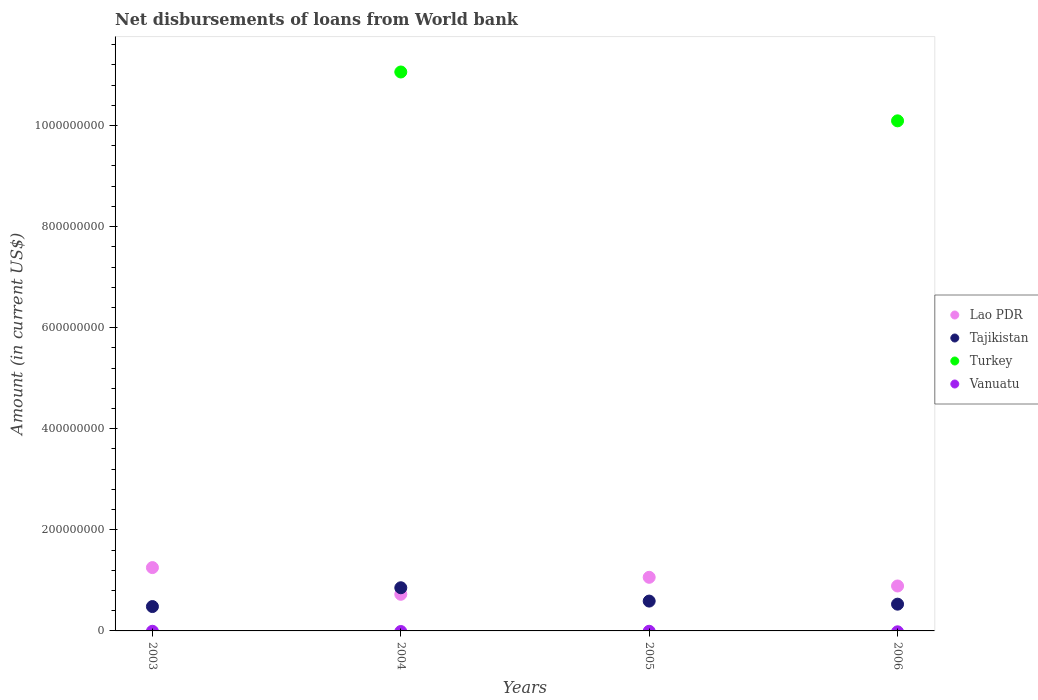How many different coloured dotlines are there?
Offer a very short reply. 3. What is the amount of loan disbursed from World Bank in Tajikistan in 2005?
Your answer should be compact. 5.90e+07. Across all years, what is the maximum amount of loan disbursed from World Bank in Turkey?
Give a very brief answer. 1.11e+09. Across all years, what is the minimum amount of loan disbursed from World Bank in Tajikistan?
Keep it short and to the point. 4.82e+07. In which year was the amount of loan disbursed from World Bank in Lao PDR maximum?
Keep it short and to the point. 2003. What is the total amount of loan disbursed from World Bank in Tajikistan in the graph?
Provide a succinct answer. 2.46e+08. What is the difference between the amount of loan disbursed from World Bank in Tajikistan in 2004 and that in 2006?
Offer a very short reply. 3.25e+07. What is the difference between the amount of loan disbursed from World Bank in Tajikistan in 2006 and the amount of loan disbursed from World Bank in Vanuatu in 2003?
Provide a short and direct response. 5.29e+07. What is the average amount of loan disbursed from World Bank in Vanuatu per year?
Make the answer very short. 0. In the year 2006, what is the difference between the amount of loan disbursed from World Bank in Lao PDR and amount of loan disbursed from World Bank in Turkey?
Provide a short and direct response. -9.20e+08. What is the ratio of the amount of loan disbursed from World Bank in Tajikistan in 2003 to that in 2006?
Give a very brief answer. 0.91. Is the difference between the amount of loan disbursed from World Bank in Lao PDR in 2004 and 2006 greater than the difference between the amount of loan disbursed from World Bank in Turkey in 2004 and 2006?
Provide a succinct answer. No. What is the difference between the highest and the second highest amount of loan disbursed from World Bank in Tajikistan?
Offer a very short reply. 2.64e+07. What is the difference between the highest and the lowest amount of loan disbursed from World Bank in Tajikistan?
Your answer should be very brief. 3.72e+07. In how many years, is the amount of loan disbursed from World Bank in Lao PDR greater than the average amount of loan disbursed from World Bank in Lao PDR taken over all years?
Your answer should be very brief. 2. Does the amount of loan disbursed from World Bank in Lao PDR monotonically increase over the years?
Offer a very short reply. No. Is the amount of loan disbursed from World Bank in Tajikistan strictly greater than the amount of loan disbursed from World Bank in Lao PDR over the years?
Keep it short and to the point. No. Is the amount of loan disbursed from World Bank in Lao PDR strictly less than the amount of loan disbursed from World Bank in Turkey over the years?
Your response must be concise. No. Are the values on the major ticks of Y-axis written in scientific E-notation?
Offer a terse response. No. Does the graph contain any zero values?
Give a very brief answer. Yes. Where does the legend appear in the graph?
Offer a terse response. Center right. What is the title of the graph?
Give a very brief answer. Net disbursements of loans from World bank. Does "Israel" appear as one of the legend labels in the graph?
Offer a very short reply. No. What is the label or title of the X-axis?
Provide a short and direct response. Years. What is the label or title of the Y-axis?
Your answer should be compact. Amount (in current US$). What is the Amount (in current US$) of Lao PDR in 2003?
Offer a very short reply. 1.25e+08. What is the Amount (in current US$) of Tajikistan in 2003?
Offer a very short reply. 4.82e+07. What is the Amount (in current US$) in Vanuatu in 2003?
Keep it short and to the point. 0. What is the Amount (in current US$) of Lao PDR in 2004?
Make the answer very short. 7.25e+07. What is the Amount (in current US$) in Tajikistan in 2004?
Offer a terse response. 8.54e+07. What is the Amount (in current US$) in Turkey in 2004?
Your response must be concise. 1.11e+09. What is the Amount (in current US$) of Vanuatu in 2004?
Your response must be concise. 0. What is the Amount (in current US$) of Lao PDR in 2005?
Make the answer very short. 1.06e+08. What is the Amount (in current US$) in Tajikistan in 2005?
Provide a succinct answer. 5.90e+07. What is the Amount (in current US$) of Turkey in 2005?
Offer a very short reply. 0. What is the Amount (in current US$) in Lao PDR in 2006?
Your response must be concise. 8.89e+07. What is the Amount (in current US$) in Tajikistan in 2006?
Your response must be concise. 5.29e+07. What is the Amount (in current US$) of Turkey in 2006?
Ensure brevity in your answer.  1.01e+09. Across all years, what is the maximum Amount (in current US$) of Lao PDR?
Your response must be concise. 1.25e+08. Across all years, what is the maximum Amount (in current US$) in Tajikistan?
Ensure brevity in your answer.  8.54e+07. Across all years, what is the maximum Amount (in current US$) of Turkey?
Offer a very short reply. 1.11e+09. Across all years, what is the minimum Amount (in current US$) in Lao PDR?
Your response must be concise. 7.25e+07. Across all years, what is the minimum Amount (in current US$) of Tajikistan?
Offer a very short reply. 4.82e+07. Across all years, what is the minimum Amount (in current US$) in Turkey?
Offer a terse response. 0. What is the total Amount (in current US$) of Lao PDR in the graph?
Make the answer very short. 3.93e+08. What is the total Amount (in current US$) of Tajikistan in the graph?
Make the answer very short. 2.46e+08. What is the total Amount (in current US$) of Turkey in the graph?
Your answer should be compact. 2.12e+09. What is the total Amount (in current US$) of Vanuatu in the graph?
Offer a very short reply. 0. What is the difference between the Amount (in current US$) of Lao PDR in 2003 and that in 2004?
Provide a short and direct response. 5.28e+07. What is the difference between the Amount (in current US$) in Tajikistan in 2003 and that in 2004?
Ensure brevity in your answer.  -3.72e+07. What is the difference between the Amount (in current US$) in Lao PDR in 2003 and that in 2005?
Your answer should be compact. 1.92e+07. What is the difference between the Amount (in current US$) of Tajikistan in 2003 and that in 2005?
Your response must be concise. -1.08e+07. What is the difference between the Amount (in current US$) in Lao PDR in 2003 and that in 2006?
Keep it short and to the point. 3.64e+07. What is the difference between the Amount (in current US$) in Tajikistan in 2003 and that in 2006?
Provide a short and direct response. -4.72e+06. What is the difference between the Amount (in current US$) of Lao PDR in 2004 and that in 2005?
Offer a terse response. -3.36e+07. What is the difference between the Amount (in current US$) of Tajikistan in 2004 and that in 2005?
Give a very brief answer. 2.64e+07. What is the difference between the Amount (in current US$) of Lao PDR in 2004 and that in 2006?
Ensure brevity in your answer.  -1.64e+07. What is the difference between the Amount (in current US$) in Tajikistan in 2004 and that in 2006?
Keep it short and to the point. 3.25e+07. What is the difference between the Amount (in current US$) of Turkey in 2004 and that in 2006?
Your answer should be very brief. 9.67e+07. What is the difference between the Amount (in current US$) of Lao PDR in 2005 and that in 2006?
Your answer should be very brief. 1.71e+07. What is the difference between the Amount (in current US$) of Tajikistan in 2005 and that in 2006?
Your response must be concise. 6.09e+06. What is the difference between the Amount (in current US$) in Lao PDR in 2003 and the Amount (in current US$) in Tajikistan in 2004?
Provide a succinct answer. 3.99e+07. What is the difference between the Amount (in current US$) in Lao PDR in 2003 and the Amount (in current US$) in Turkey in 2004?
Offer a terse response. -9.81e+08. What is the difference between the Amount (in current US$) in Tajikistan in 2003 and the Amount (in current US$) in Turkey in 2004?
Offer a terse response. -1.06e+09. What is the difference between the Amount (in current US$) of Lao PDR in 2003 and the Amount (in current US$) of Tajikistan in 2005?
Provide a succinct answer. 6.63e+07. What is the difference between the Amount (in current US$) in Lao PDR in 2003 and the Amount (in current US$) in Tajikistan in 2006?
Your response must be concise. 7.24e+07. What is the difference between the Amount (in current US$) in Lao PDR in 2003 and the Amount (in current US$) in Turkey in 2006?
Keep it short and to the point. -8.84e+08. What is the difference between the Amount (in current US$) in Tajikistan in 2003 and the Amount (in current US$) in Turkey in 2006?
Ensure brevity in your answer.  -9.61e+08. What is the difference between the Amount (in current US$) of Lao PDR in 2004 and the Amount (in current US$) of Tajikistan in 2005?
Your answer should be compact. 1.35e+07. What is the difference between the Amount (in current US$) in Lao PDR in 2004 and the Amount (in current US$) in Tajikistan in 2006?
Keep it short and to the point. 1.95e+07. What is the difference between the Amount (in current US$) in Lao PDR in 2004 and the Amount (in current US$) in Turkey in 2006?
Provide a succinct answer. -9.37e+08. What is the difference between the Amount (in current US$) in Tajikistan in 2004 and the Amount (in current US$) in Turkey in 2006?
Provide a succinct answer. -9.24e+08. What is the difference between the Amount (in current US$) in Lao PDR in 2005 and the Amount (in current US$) in Tajikistan in 2006?
Provide a short and direct response. 5.31e+07. What is the difference between the Amount (in current US$) in Lao PDR in 2005 and the Amount (in current US$) in Turkey in 2006?
Give a very brief answer. -9.03e+08. What is the difference between the Amount (in current US$) of Tajikistan in 2005 and the Amount (in current US$) of Turkey in 2006?
Provide a succinct answer. -9.50e+08. What is the average Amount (in current US$) of Lao PDR per year?
Your response must be concise. 9.82e+07. What is the average Amount (in current US$) in Tajikistan per year?
Make the answer very short. 6.14e+07. What is the average Amount (in current US$) in Turkey per year?
Your answer should be compact. 5.29e+08. In the year 2003, what is the difference between the Amount (in current US$) of Lao PDR and Amount (in current US$) of Tajikistan?
Your response must be concise. 7.71e+07. In the year 2004, what is the difference between the Amount (in current US$) of Lao PDR and Amount (in current US$) of Tajikistan?
Provide a succinct answer. -1.29e+07. In the year 2004, what is the difference between the Amount (in current US$) of Lao PDR and Amount (in current US$) of Turkey?
Provide a succinct answer. -1.03e+09. In the year 2004, what is the difference between the Amount (in current US$) in Tajikistan and Amount (in current US$) in Turkey?
Give a very brief answer. -1.02e+09. In the year 2005, what is the difference between the Amount (in current US$) in Lao PDR and Amount (in current US$) in Tajikistan?
Ensure brevity in your answer.  4.71e+07. In the year 2006, what is the difference between the Amount (in current US$) in Lao PDR and Amount (in current US$) in Tajikistan?
Keep it short and to the point. 3.60e+07. In the year 2006, what is the difference between the Amount (in current US$) of Lao PDR and Amount (in current US$) of Turkey?
Provide a succinct answer. -9.20e+08. In the year 2006, what is the difference between the Amount (in current US$) in Tajikistan and Amount (in current US$) in Turkey?
Your response must be concise. -9.56e+08. What is the ratio of the Amount (in current US$) in Lao PDR in 2003 to that in 2004?
Give a very brief answer. 1.73. What is the ratio of the Amount (in current US$) in Tajikistan in 2003 to that in 2004?
Keep it short and to the point. 0.56. What is the ratio of the Amount (in current US$) in Lao PDR in 2003 to that in 2005?
Provide a short and direct response. 1.18. What is the ratio of the Amount (in current US$) of Tajikistan in 2003 to that in 2005?
Keep it short and to the point. 0.82. What is the ratio of the Amount (in current US$) in Lao PDR in 2003 to that in 2006?
Make the answer very short. 1.41. What is the ratio of the Amount (in current US$) in Tajikistan in 2003 to that in 2006?
Offer a very short reply. 0.91. What is the ratio of the Amount (in current US$) of Lao PDR in 2004 to that in 2005?
Your response must be concise. 0.68. What is the ratio of the Amount (in current US$) in Tajikistan in 2004 to that in 2005?
Your answer should be very brief. 1.45. What is the ratio of the Amount (in current US$) in Lao PDR in 2004 to that in 2006?
Offer a terse response. 0.82. What is the ratio of the Amount (in current US$) in Tajikistan in 2004 to that in 2006?
Provide a succinct answer. 1.61. What is the ratio of the Amount (in current US$) in Turkey in 2004 to that in 2006?
Your answer should be very brief. 1.1. What is the ratio of the Amount (in current US$) in Lao PDR in 2005 to that in 2006?
Give a very brief answer. 1.19. What is the ratio of the Amount (in current US$) in Tajikistan in 2005 to that in 2006?
Make the answer very short. 1.11. What is the difference between the highest and the second highest Amount (in current US$) in Lao PDR?
Your answer should be very brief. 1.92e+07. What is the difference between the highest and the second highest Amount (in current US$) in Tajikistan?
Your answer should be compact. 2.64e+07. What is the difference between the highest and the lowest Amount (in current US$) of Lao PDR?
Offer a very short reply. 5.28e+07. What is the difference between the highest and the lowest Amount (in current US$) in Tajikistan?
Offer a terse response. 3.72e+07. What is the difference between the highest and the lowest Amount (in current US$) in Turkey?
Give a very brief answer. 1.11e+09. 